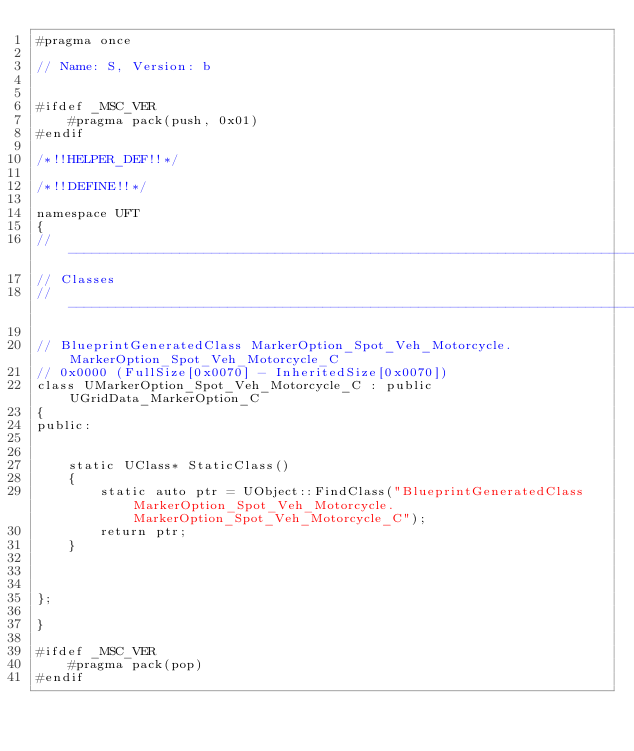Convert code to text. <code><loc_0><loc_0><loc_500><loc_500><_C_>#pragma once

// Name: S, Version: b


#ifdef _MSC_VER
	#pragma pack(push, 0x01)
#endif

/*!!HELPER_DEF!!*/

/*!!DEFINE!!*/

namespace UFT
{
//---------------------------------------------------------------------------
// Classes
//---------------------------------------------------------------------------

// BlueprintGeneratedClass MarkerOption_Spot_Veh_Motorcycle.MarkerOption_Spot_Veh_Motorcycle_C
// 0x0000 (FullSize[0x0070] - InheritedSize[0x0070])
class UMarkerOption_Spot_Veh_Motorcycle_C : public UGridData_MarkerOption_C
{
public:


	static UClass* StaticClass()
	{
		static auto ptr = UObject::FindClass("BlueprintGeneratedClass MarkerOption_Spot_Veh_Motorcycle.MarkerOption_Spot_Veh_Motorcycle_C");
		return ptr;
	}



};

}

#ifdef _MSC_VER
	#pragma pack(pop)
#endif
</code> 